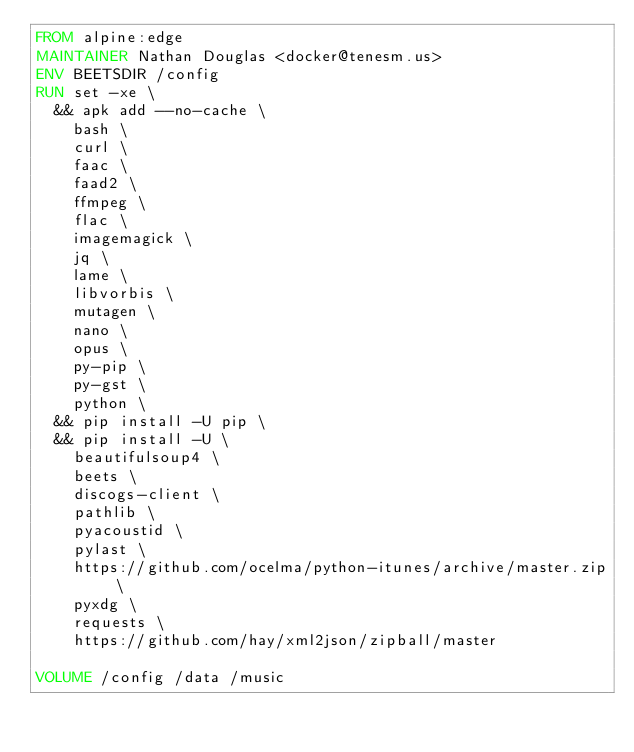<code> <loc_0><loc_0><loc_500><loc_500><_Dockerfile_>FROM alpine:edge
MAINTAINER Nathan Douglas <docker@tenesm.us>
ENV BEETSDIR /config
RUN set -xe \
  && apk add --no-cache \
    bash \
    curl \
    faac \
    faad2 \
    ffmpeg \
    flac \
    imagemagick \
    jq \
    lame \
    libvorbis \
    mutagen \
    nano \
    opus \
    py-pip \
    py-gst \
    python \
  && pip install -U pip \
  && pip install -U \
    beautifulsoup4 \
    beets \
    discogs-client \
    pathlib \
    pyacoustid \
    pylast \
    https://github.com/ocelma/python-itunes/archive/master.zip \
    pyxdg \
    requests \
    https://github.com/hay/xml2json/zipball/master

VOLUME /config /data /music
</code> 